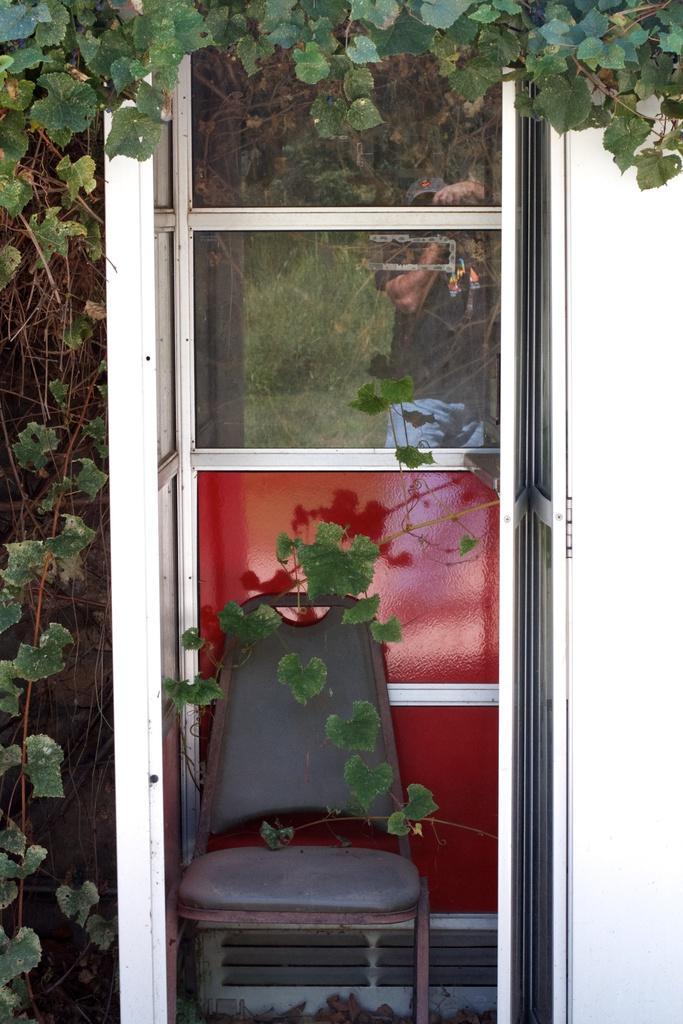Please provide a concise description of this image. In this picture we can see the door, chair and some plants. 